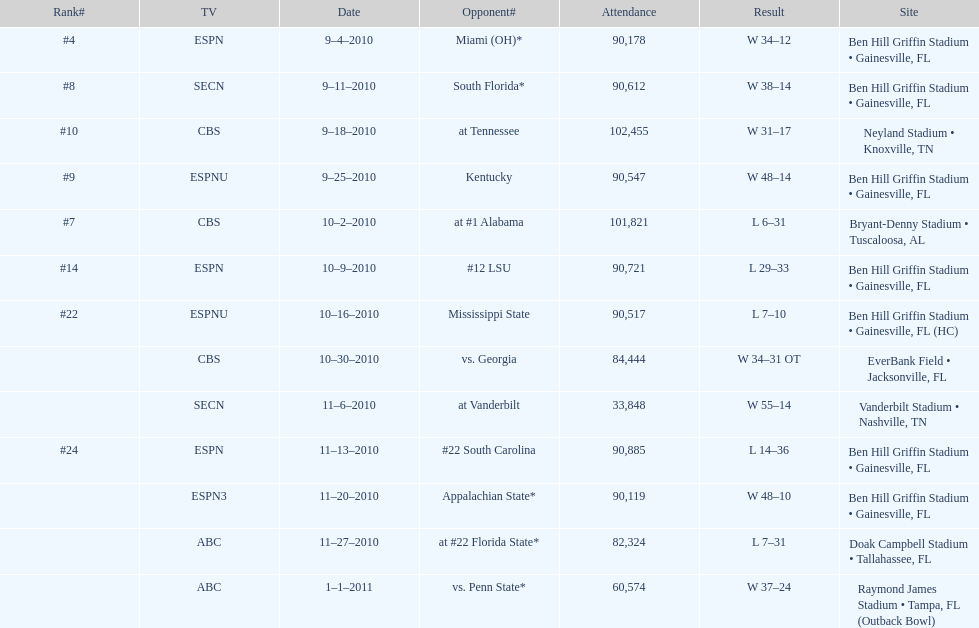What is the number of games played in teh 2010-2011 season 13. 